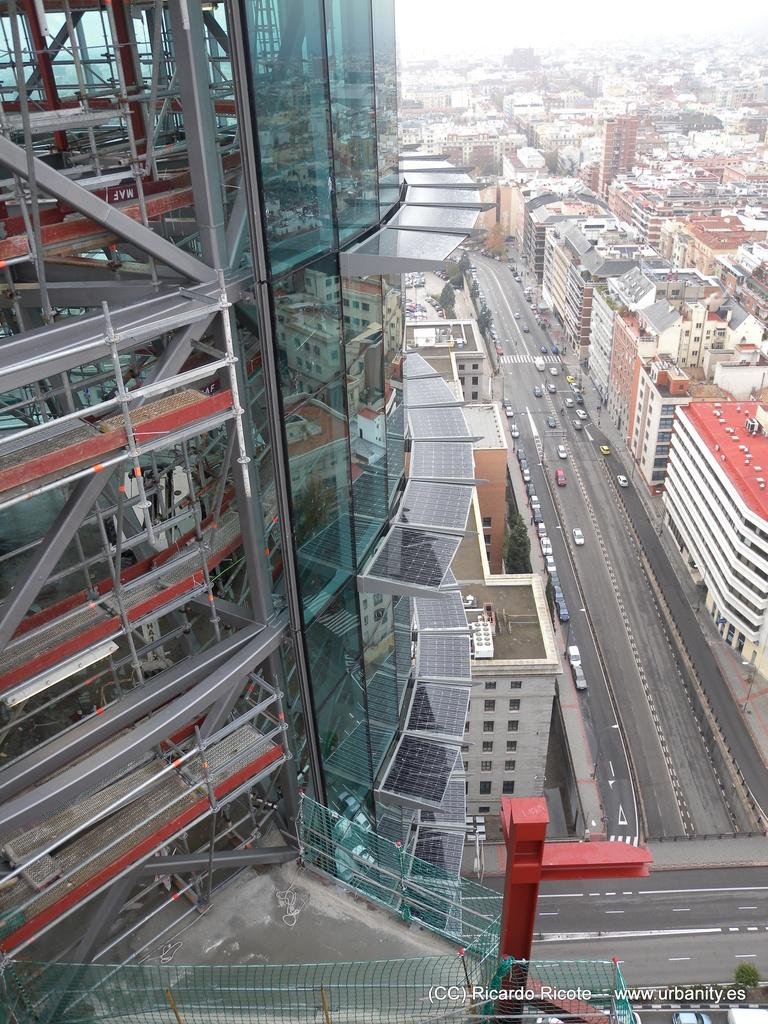What is the main subject of the image? The image provides an overview of a city. What is located at the bottom of the image? There is a net at the bottom of the image. What type of structures can be seen on both sides of the image? Buildings are present on both sides of the image. What type of transportation can be seen in the image? Cars are moving on the road in the image. What type of office can be seen in the image? There is no office present in the image; it provides an overview of a city with buildings and cars. Can you tell me who the partner is in the image? There is no partner present in the image; it is a cityscape with no specific individuals or relationships depicted. 